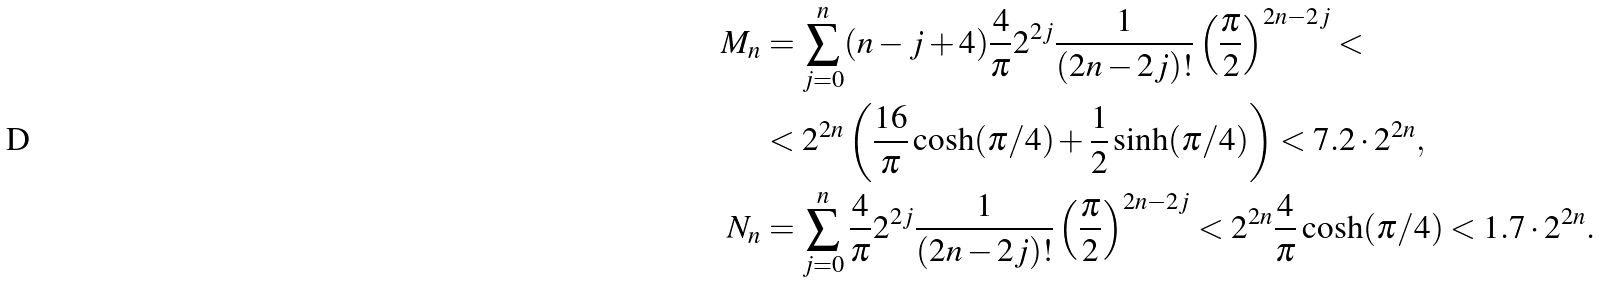Convert formula to latex. <formula><loc_0><loc_0><loc_500><loc_500>M _ { n } & = \sum _ { j = 0 } ^ { n } ( n - j + 4 ) \frac { 4 } { \pi } 2 ^ { 2 j } \frac { 1 } { ( 2 n - 2 j ) ! } \left ( \frac { \pi } { 2 } \right ) ^ { 2 n - 2 j } < \\ & < 2 ^ { 2 n } \left ( \frac { 1 6 } { \pi } \cosh ( \pi / 4 ) + \frac { 1 } { 2 } \sinh ( \pi / 4 ) \right ) < 7 . 2 \cdot 2 ^ { 2 n } , \\ N _ { n } & = \sum _ { j = 0 } ^ { n } \frac { 4 } { \pi } 2 ^ { 2 j } \frac { 1 } { ( 2 n - 2 j ) ! } \left ( \frac { \pi } { 2 } \right ) ^ { 2 n - 2 j } < 2 ^ { 2 n } \frac { 4 } { \pi } \cosh ( \pi / 4 ) < 1 . 7 \cdot 2 ^ { 2 n } .</formula> 